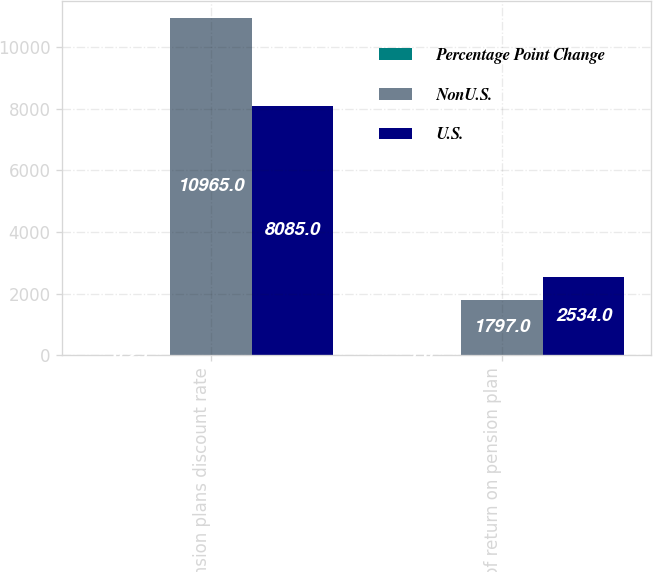Convert chart to OTSL. <chart><loc_0><loc_0><loc_500><loc_500><stacked_bar_chart><ecel><fcel>Pension plans discount rate<fcel>Rate of return on pension plan<nl><fcel>Percentage Point Change<fcel>0.25<fcel>1<nl><fcel>NonU.S.<fcel>10965<fcel>1797<nl><fcel>U.S.<fcel>8085<fcel>2534<nl></chart> 